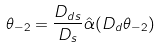<formula> <loc_0><loc_0><loc_500><loc_500>\theta _ { - 2 } = { \frac { D _ { d s } } { D _ { s } } } \hat { \alpha } ( D _ { d } \theta _ { - 2 } )</formula> 